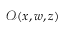<formula> <loc_0><loc_0><loc_500><loc_500>\mathcal { O } ( x , w , z )</formula> 